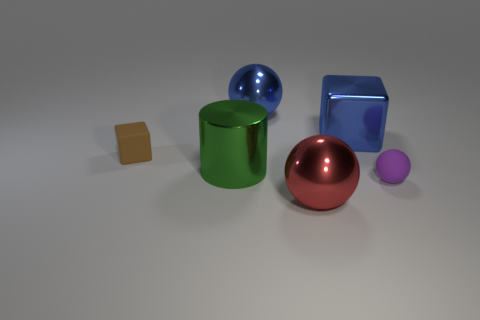Subtract all purple spheres. How many spheres are left? 2 Add 2 blue metal things. How many objects exist? 8 Subtract all purple balls. How many balls are left? 2 Subtract all gray cylinders. How many cyan balls are left? 0 Subtract all large gray cylinders. Subtract all big red shiny balls. How many objects are left? 5 Add 5 big red objects. How many big red objects are left? 6 Add 1 tiny blue rubber objects. How many tiny blue rubber objects exist? 1 Subtract 0 brown balls. How many objects are left? 6 Subtract all blocks. How many objects are left? 4 Subtract 1 blocks. How many blocks are left? 1 